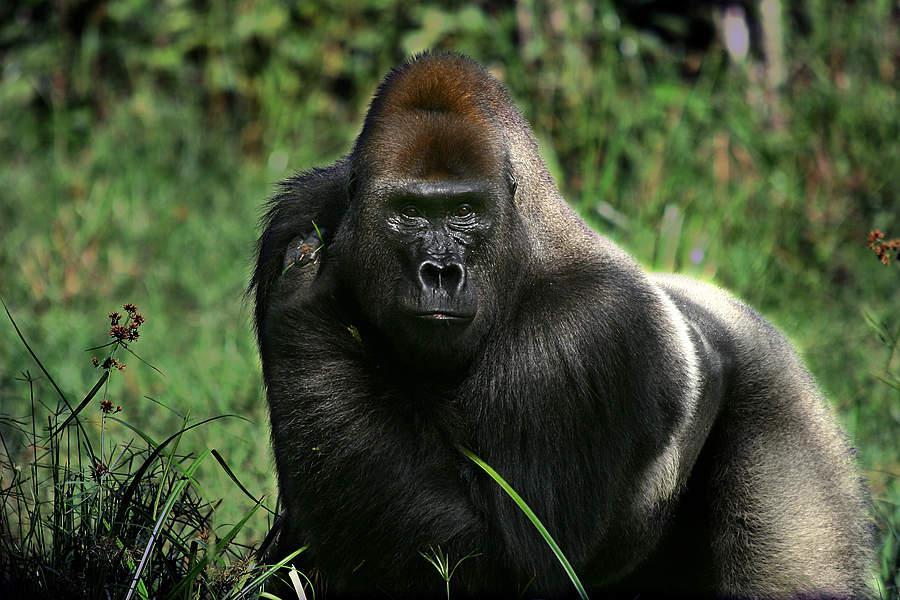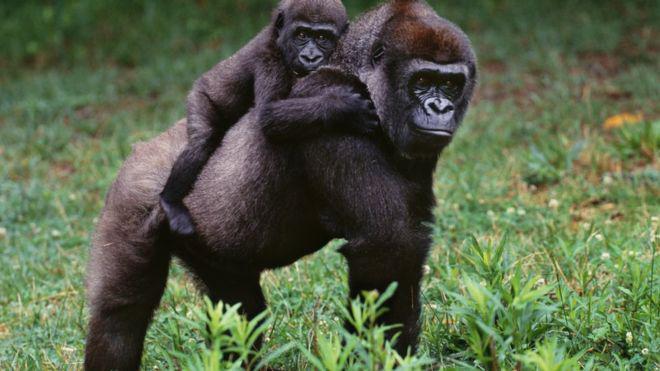The first image is the image on the left, the second image is the image on the right. For the images displayed, is the sentence "One image shows just one gorilla, a male on all fours with its body turned leftward, and the other image contains two apes, one a tiny baby." factually correct? Answer yes or no. Yes. The first image is the image on the left, the second image is the image on the right. Examine the images to the left and right. Is the description "One primate is carrying a younger primate." accurate? Answer yes or no. Yes. 